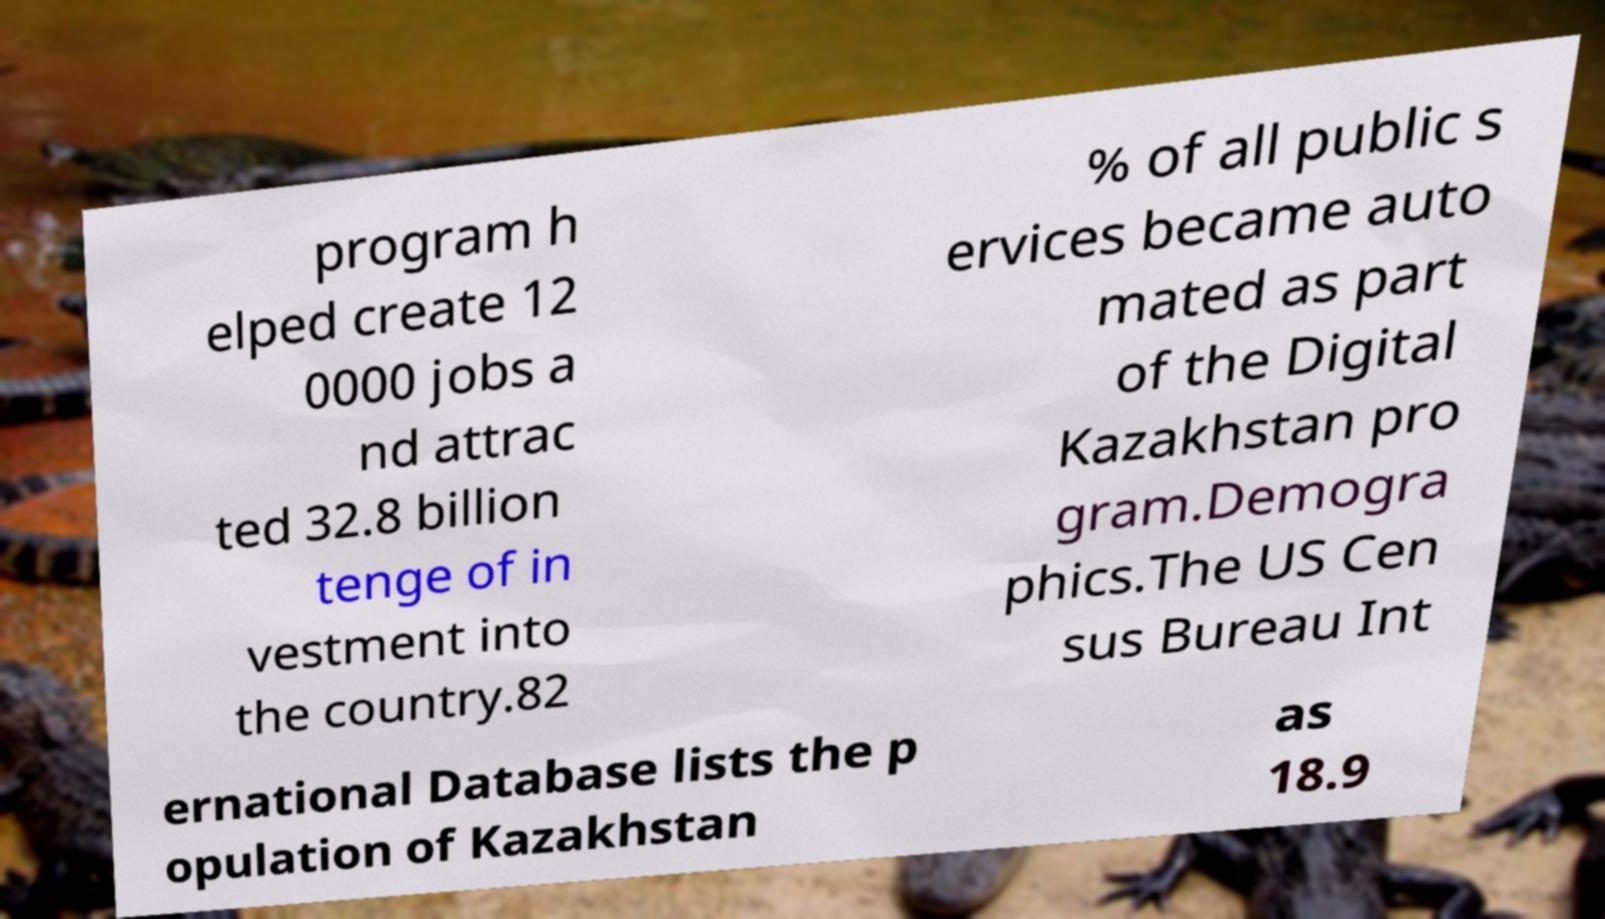Please identify and transcribe the text found in this image. program h elped create 12 0000 jobs a nd attrac ted 32.8 billion tenge of in vestment into the country.82 % of all public s ervices became auto mated as part of the Digital Kazakhstan pro gram.Demogra phics.The US Cen sus Bureau Int ernational Database lists the p opulation of Kazakhstan as 18.9 